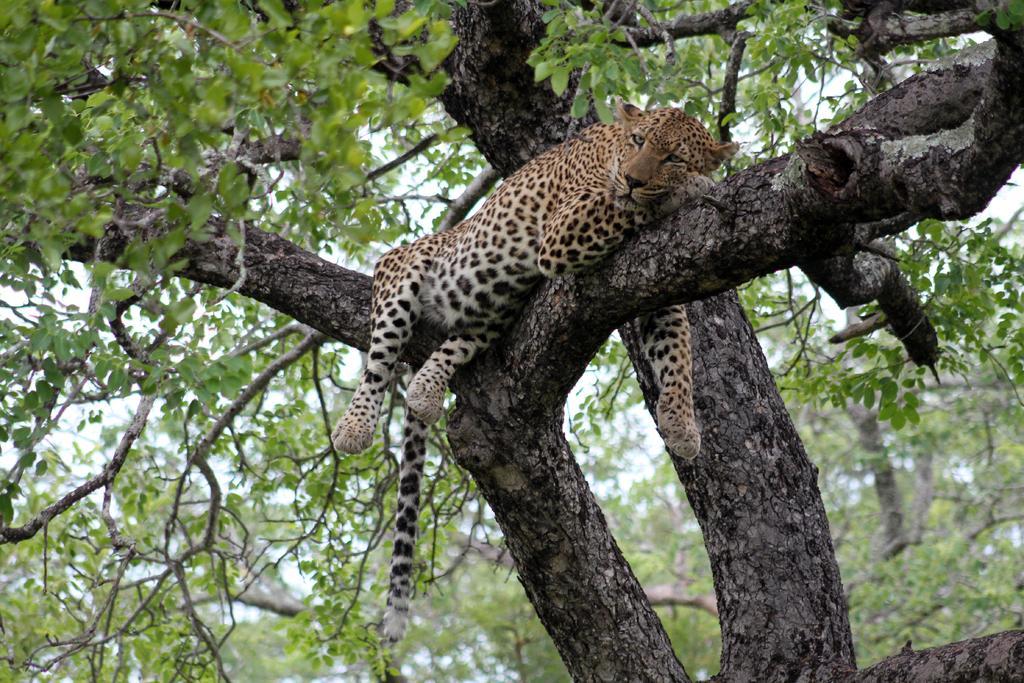Describe this image in one or two sentences. This picture might be taken from forest. In this image, in the middle, we can see a cheetah lying on the wooden trunk. In the background, we can see some tree and a sky. 